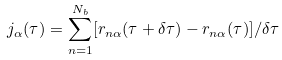<formula> <loc_0><loc_0><loc_500><loc_500>j _ { \alpha } ( \tau ) = \sum _ { n = 1 } ^ { N _ { b } } [ r _ { n \alpha } ( \tau + \delta \tau ) - r _ { n \alpha } ( \tau ) ] / \delta \tau</formula> 